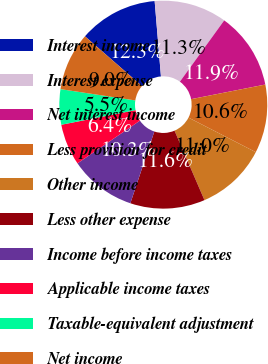Convert chart to OTSL. <chart><loc_0><loc_0><loc_500><loc_500><pie_chart><fcel>Interest income<fcel>Interest expense<fcel>Net interest income<fcel>Less provision for credit<fcel>Other income<fcel>Less other expense<fcel>Income before income taxes<fcel>Applicable income taxes<fcel>Taxable-equivalent adjustment<fcel>Net income<nl><fcel>12.26%<fcel>11.29%<fcel>11.94%<fcel>10.65%<fcel>10.97%<fcel>11.61%<fcel>10.32%<fcel>6.45%<fcel>5.48%<fcel>9.03%<nl></chart> 